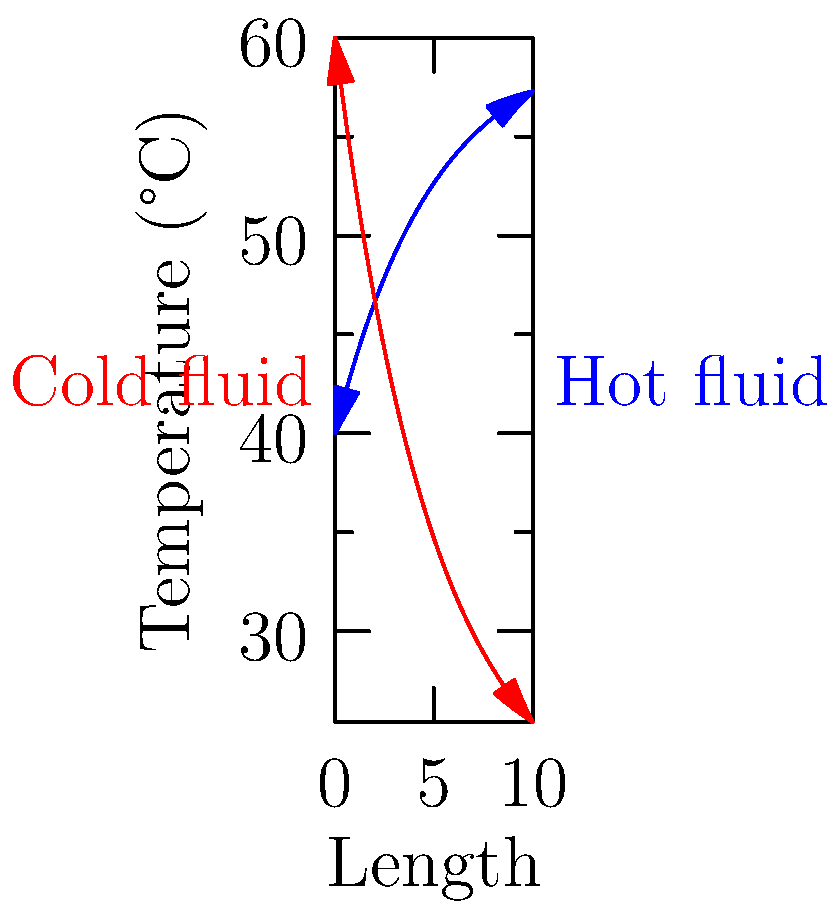In a counter-flow heat exchanger, the hot fluid enters at 60°C and exits at 40°C, while the cold fluid enters at 20°C. If the temperature distribution follows an exponential curve as shown in the graph, what is the exit temperature of the cold fluid? To solve this problem, we need to follow these steps:

1. Identify the given information:
   - Hot fluid inlet temperature: 60°C
   - Hot fluid outlet temperature: 40°C
   - Cold fluid inlet temperature: 20°C
   - The temperature distribution follows an exponential curve

2. Analyze the graph:
   - The blue line represents the hot fluid (starts at 60°C)
   - The red line represents the cold fluid (starts at 20°C)
   - The x-axis represents the length of the heat exchanger
   - The y-axis represents the temperature in °C

3. Observe the behavior of the curves:
   - The hot fluid temperature decreases exponentially
   - The cold fluid temperature increases exponentially
   - The curves approach each other but do not intersect

4. Find the exit temperature of the cold fluid:
   - The exit temperature of the cold fluid is where the red line ends on the right side of the graph
   - By visual inspection, we can see that the red line ends at approximately 40°C

5. Verify the result:
   - The temperature difference between the hot and cold fluids at both ends of the heat exchanger should be similar due to the counter-flow arrangement
   - At the left end: 60°C - 20°C = 40°C
   - At the right end: 40°C - 40°C = 0°C
   - This confirms that our estimate of 40°C for the cold fluid exit temperature is reasonable

Therefore, based on the given graph and information, the exit temperature of the cold fluid in this counter-flow heat exchanger is approximately 40°C.
Answer: 40°C 